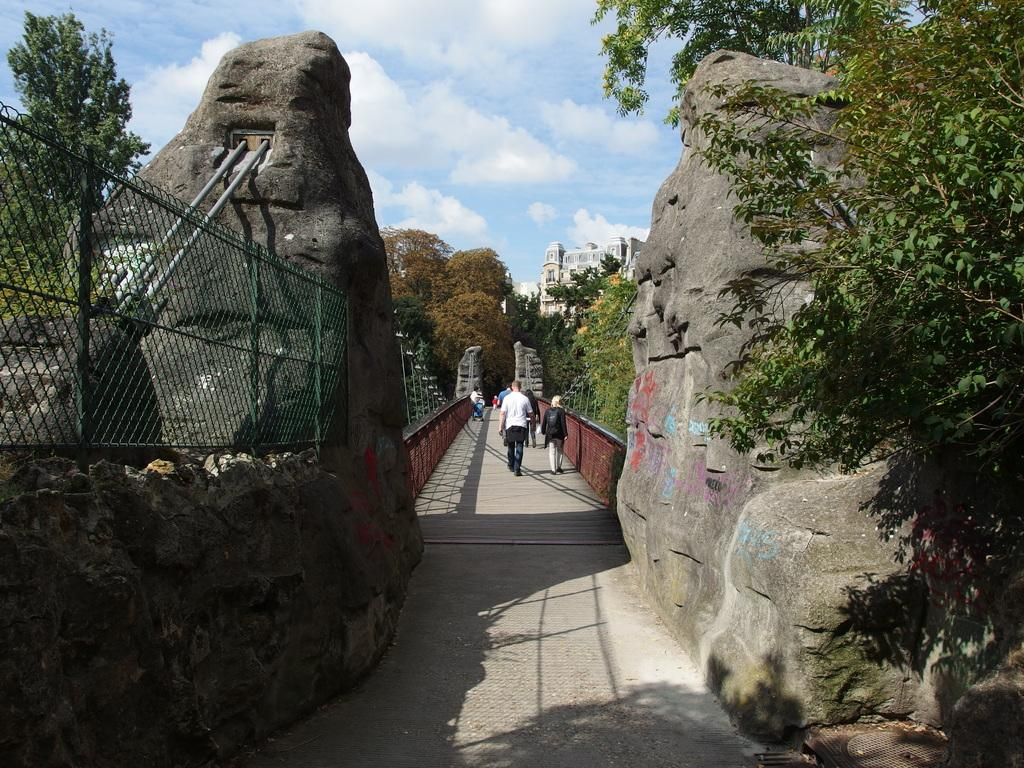What type of material is present in the image? There is welded wire mesh in the image. What natural elements can be seen in the image? There are rocks, trees, and clouds in the sky in the image. What man-made structures are visible in the image? There are poles, buildings, and people in the image. What is visible in the background of the image? The sky is visible in the background of the image, with clouds present. Can you describe the motion of the flowers in the image? There are no flowers present in the image, so we cannot describe their motion. How many times have the people in the image folded the welded wire mesh? There is no indication of folding or any action involving the welded wire mesh in the image. 